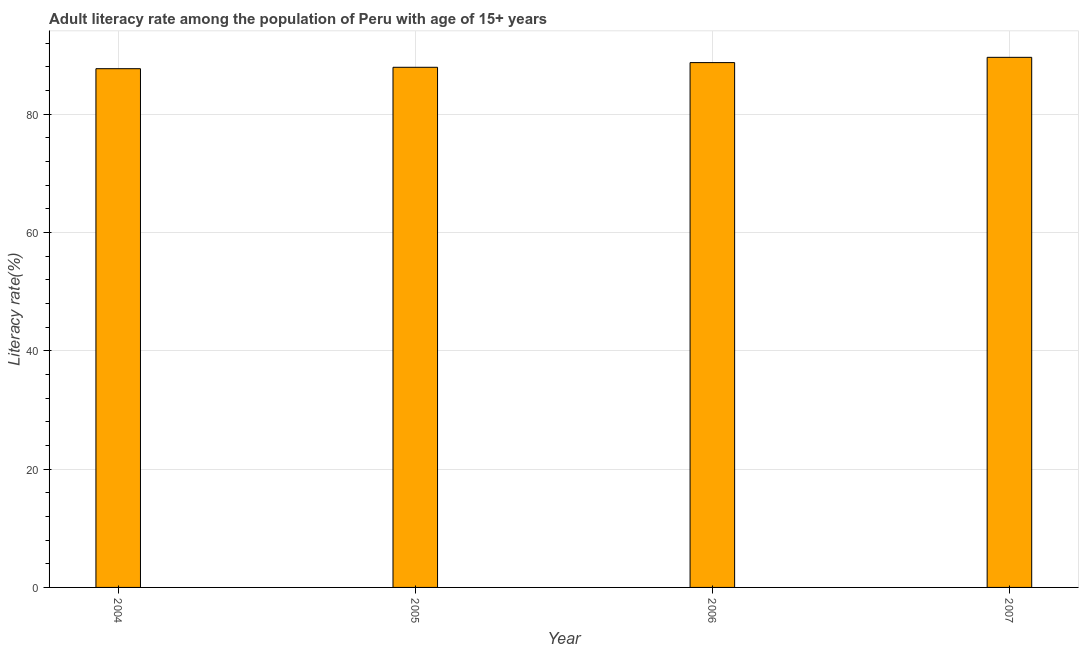What is the title of the graph?
Offer a terse response. Adult literacy rate among the population of Peru with age of 15+ years. What is the label or title of the Y-axis?
Your response must be concise. Literacy rate(%). What is the adult literacy rate in 2004?
Make the answer very short. 87.67. Across all years, what is the maximum adult literacy rate?
Give a very brief answer. 89.59. Across all years, what is the minimum adult literacy rate?
Your response must be concise. 87.67. In which year was the adult literacy rate maximum?
Provide a short and direct response. 2007. In which year was the adult literacy rate minimum?
Your response must be concise. 2004. What is the sum of the adult literacy rate?
Offer a terse response. 353.87. What is the difference between the adult literacy rate in 2004 and 2006?
Your answer should be compact. -1.03. What is the average adult literacy rate per year?
Provide a succinct answer. 88.47. What is the median adult literacy rate?
Your answer should be very brief. 88.3. What is the ratio of the adult literacy rate in 2004 to that in 2005?
Make the answer very short. 1. Is the adult literacy rate in 2006 less than that in 2007?
Your answer should be compact. Yes. Is the difference between the adult literacy rate in 2005 and 2007 greater than the difference between any two years?
Keep it short and to the point. No. What is the difference between the highest and the second highest adult literacy rate?
Your answer should be compact. 0.89. Is the sum of the adult literacy rate in 2004 and 2005 greater than the maximum adult literacy rate across all years?
Provide a short and direct response. Yes. What is the difference between the highest and the lowest adult literacy rate?
Make the answer very short. 1.92. How many bars are there?
Your answer should be very brief. 4. Are all the bars in the graph horizontal?
Give a very brief answer. No. What is the difference between two consecutive major ticks on the Y-axis?
Make the answer very short. 20. Are the values on the major ticks of Y-axis written in scientific E-notation?
Offer a terse response. No. What is the Literacy rate(%) of 2004?
Offer a terse response. 87.67. What is the Literacy rate(%) in 2005?
Offer a very short reply. 87.91. What is the Literacy rate(%) in 2006?
Ensure brevity in your answer.  88.7. What is the Literacy rate(%) of 2007?
Your response must be concise. 89.59. What is the difference between the Literacy rate(%) in 2004 and 2005?
Provide a succinct answer. -0.24. What is the difference between the Literacy rate(%) in 2004 and 2006?
Provide a succinct answer. -1.03. What is the difference between the Literacy rate(%) in 2004 and 2007?
Your answer should be very brief. -1.92. What is the difference between the Literacy rate(%) in 2005 and 2006?
Keep it short and to the point. -0.79. What is the difference between the Literacy rate(%) in 2005 and 2007?
Offer a terse response. -1.68. What is the difference between the Literacy rate(%) in 2006 and 2007?
Provide a short and direct response. -0.89. What is the ratio of the Literacy rate(%) in 2004 to that in 2005?
Provide a succinct answer. 1. What is the ratio of the Literacy rate(%) in 2004 to that in 2007?
Give a very brief answer. 0.98. What is the ratio of the Literacy rate(%) in 2005 to that in 2006?
Offer a very short reply. 0.99. What is the ratio of the Literacy rate(%) in 2005 to that in 2007?
Offer a terse response. 0.98. 